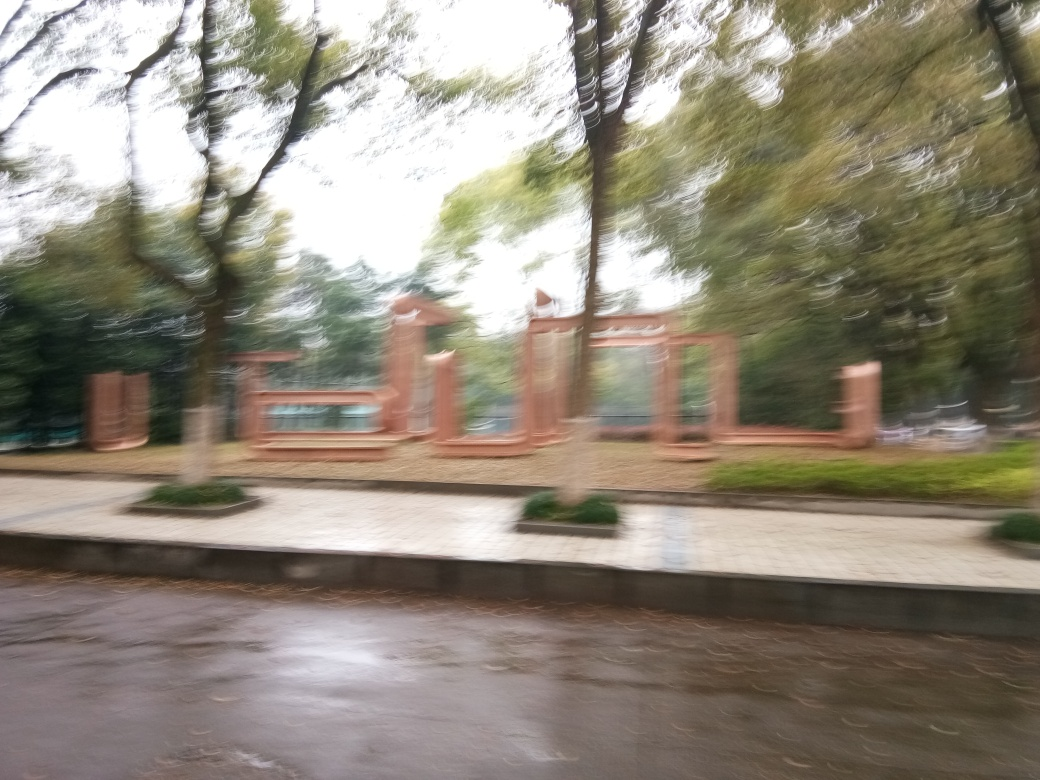Are there any quality issues with this image? Yes, the image appears to be blurred, likely due to camera motion or possibly a low shutter speed in low lighting conditions. This results in a lack of sharpness and detail that can make it challenging to discern fine details of the scene depicted. 